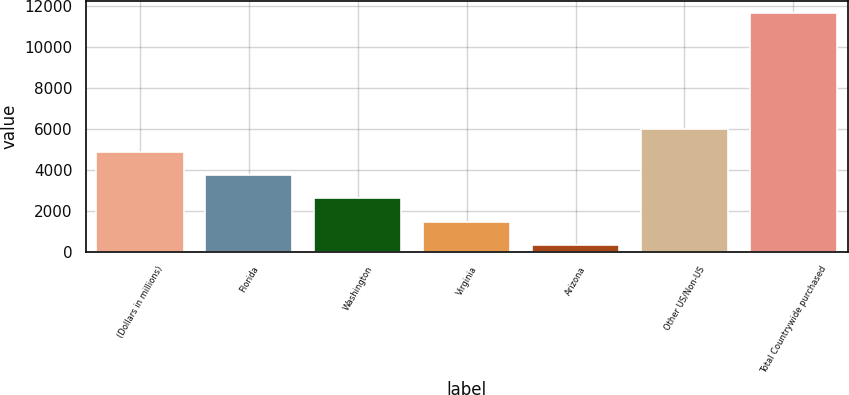Convert chart. <chart><loc_0><loc_0><loc_500><loc_500><bar_chart><fcel>(Dollars in millions)<fcel>Florida<fcel>Washington<fcel>Virginia<fcel>Arizona<fcel>Other US/Non-US<fcel>Total Countrywide purchased<nl><fcel>4864.2<fcel>3732.9<fcel>2601.6<fcel>1470.3<fcel>339<fcel>5995.5<fcel>11652<nl></chart> 